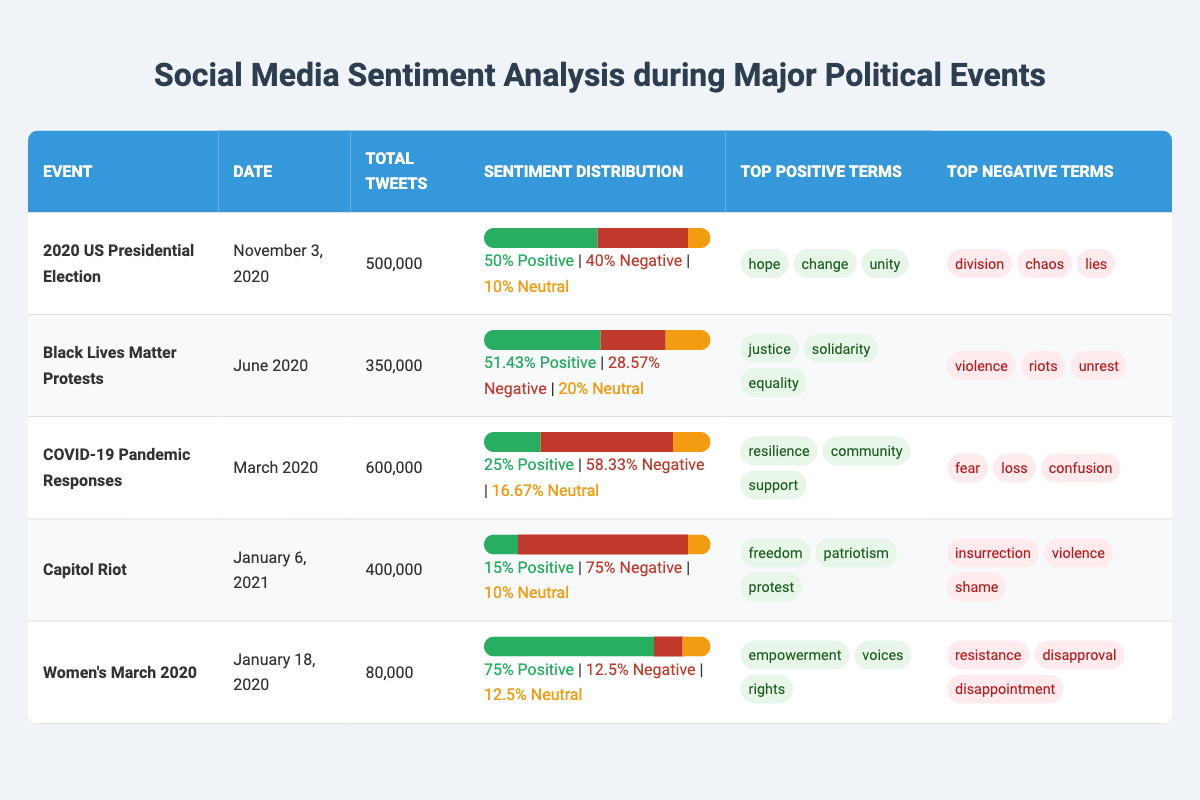What was the total number of tweets during the Black Lives Matter Protests? The table shows that there were 350,000 total tweets for this event.
Answer: 350,000 Which event had the highest percentage of positive sentiment? When comparing the positive sentiment percentages, the Women's March 2020 had the highest at 75%.
Answer: Women's March 2020 What are the top positive terms for the Capitol Riot event? The top positive terms listed for the Capitol Riot are "freedom," "patriotism," and "protest."
Answer: Freedom, patriotism, protest How many events had more negative than positive sentiment? By analyzing the sentiment percentages, three events—COVID-19 Pandemic Responses, Capitol Riot, and 2020 US Presidential Election—had more negative sentiment than positive sentiment.
Answer: Three events What is the difference between the total number of tweets during the COVID-19 Pandemic Responses and the Women's March 2020? The COVID-19 Pandemic Responses had 600,000 tweets, and the Women's March 2020 had 80,000 tweets. Hence, the difference is 600,000 - 80,000 = 520,000.
Answer: 520,000 Which event had the lowest percentage of neutral sentiment? The Capitol Riot had a neutral sentiment percentage of 10%, which is the lowest among the listed events.
Answer: Capitol Riot What is the average number of tweets across all events? To find the average, sum the total tweets of all events: 500,000 + 350,000 + 600,000 + 400,000 + 80,000 = 1,930,000. Then divide by the number of events (5). The average is 1,930,000 / 5 = 386,000.
Answer: 386,000 Did the Black Lives Matter Protests have significantly more positive sentiment than the Capitol Riot? Yes, the Black Lives Matter Protests had a positive sentiment percentage of 51.43%, while the Capitol Riot had only 15%, indicating a significant difference.
Answer: Yes What percentage of tweets during the COVID-19 Pandemic Responses were neutral? The table indicates that the neutral sentiment for the COVID-19 Pandemic Responses was 16.67%.
Answer: 16.67% Which event had the most negative sentiment terms listed? The Capitol Riot had the most negative sentiment terms listed, including "insurrection," "violence," and "shame."
Answer: Capitol Riot 